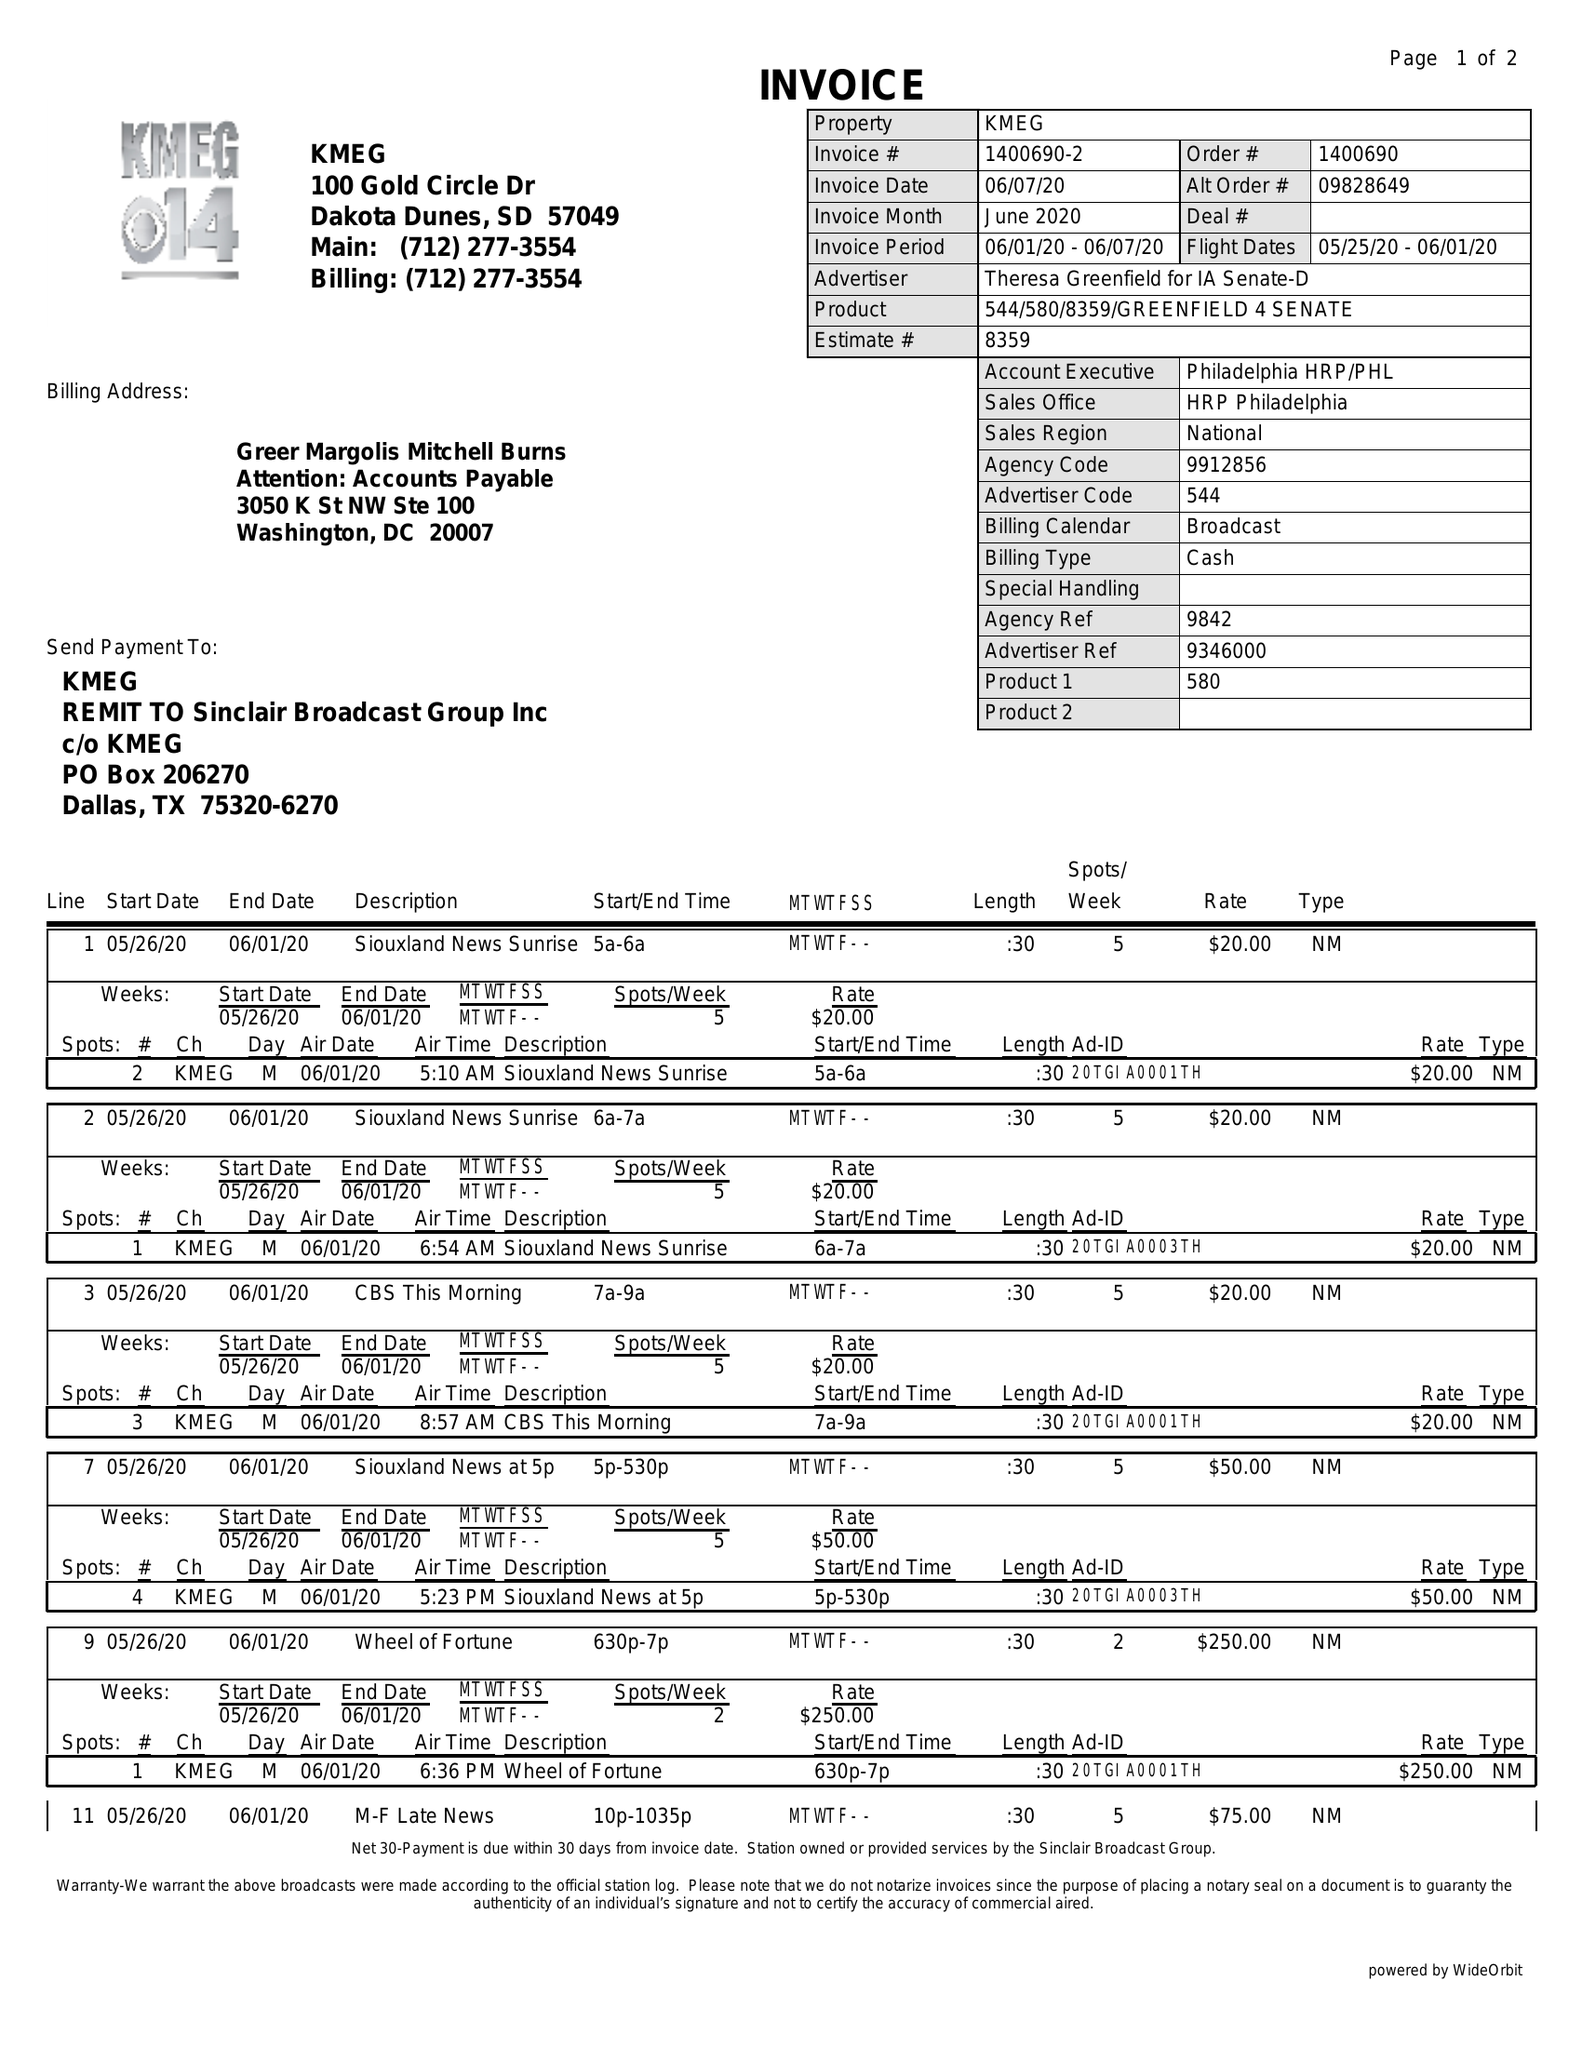What is the value for the contract_num?
Answer the question using a single word or phrase. 1400690 